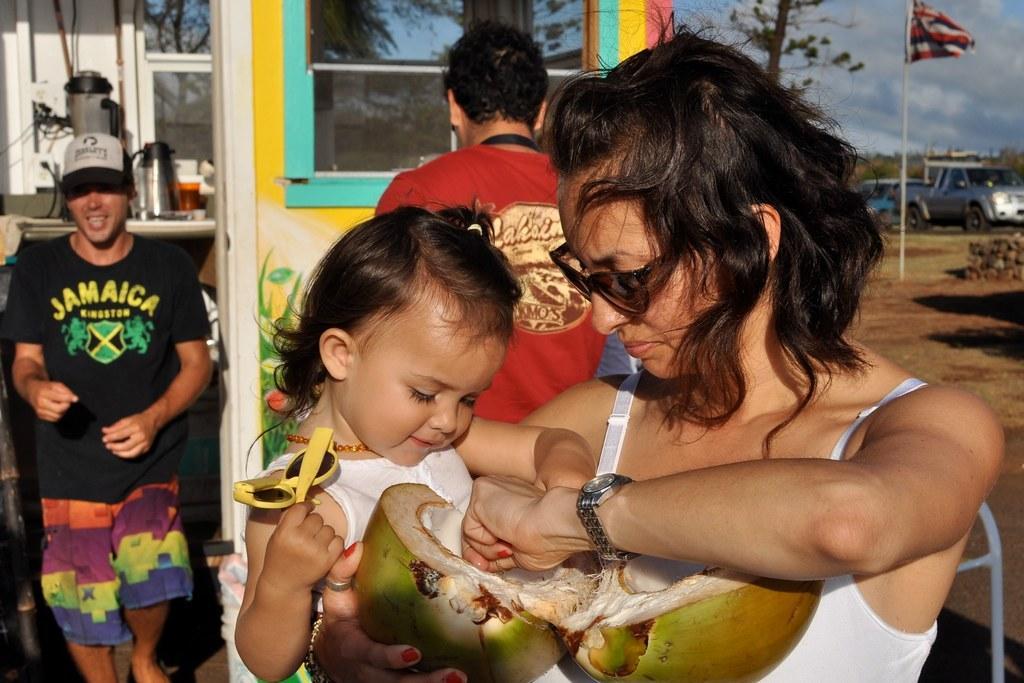Could you give a brief overview of what you see in this image? In this picture there is a woman standing and holding the baby and coconut and the baby is holding the goggles. At the back there are two persons and there is a building and there is a kettle and cup on the table and there is a reflection of trees and sky on the mirror. On the right side of the mage there are vehicles and there is a flag and there are trees. At the top there is sky and there are clouds. At the bottom there is mud. 